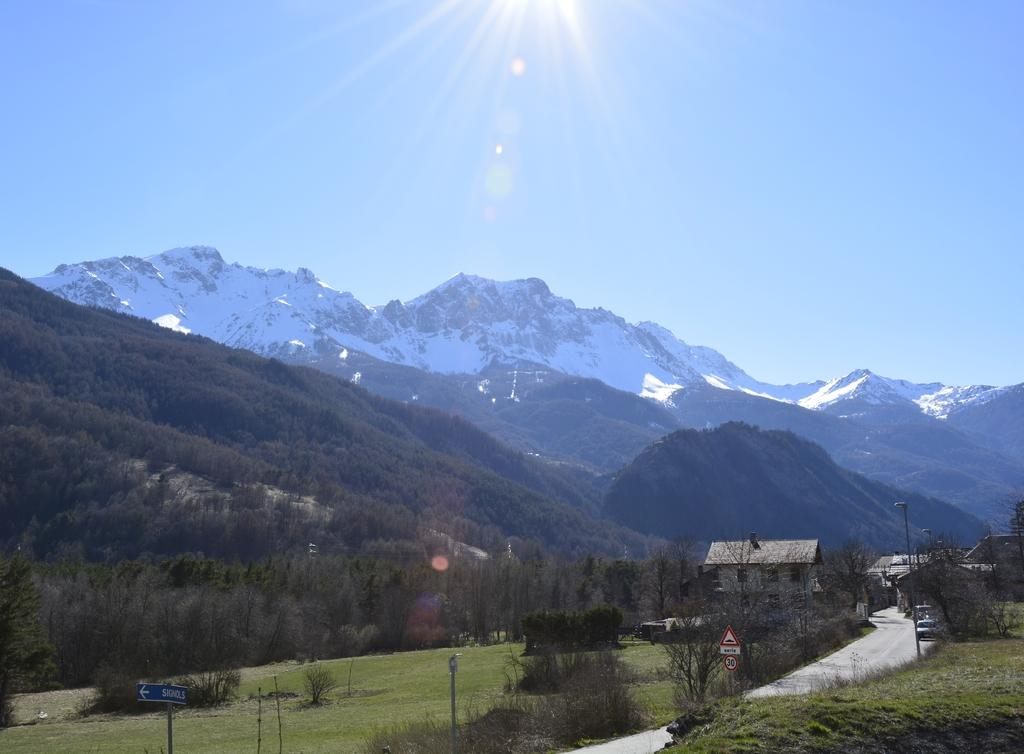What type of ground is visible in the image? The ground with grass is visible in the image. What type of vegetation can be seen in the image? Plants, trees, and grass are visible in the image. What structures are present in the image? Poles, houses, and signboards are visible in the image. What features can be seen on the houses in the image? Houses with doors and windows are visible in the image. What natural landmarks are visible in the image? Mountains are visible in the image. What can be seen in the sky in the image? The sky, sunshine, and clouds are visible in the image. What type of stem can be seen growing from the mailbox in the image? There is no mailbox present in the image, so there is no stem growing from it. 